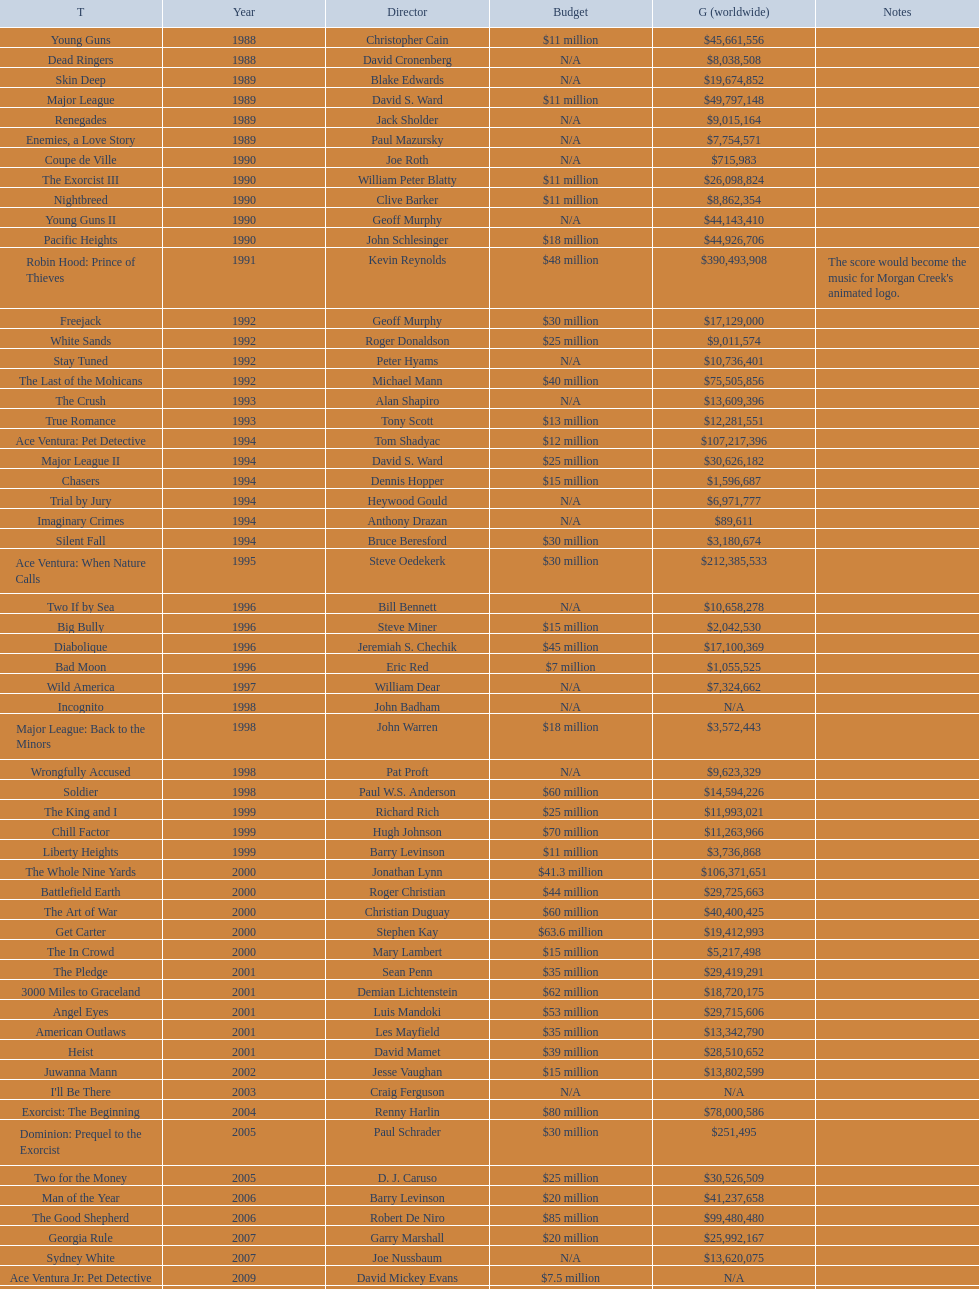Write the full table. {'header': ['T', 'Year', 'Director', 'Budget', 'G (worldwide)', 'Notes'], 'rows': [['Young Guns', '1988', 'Christopher Cain', '$11 million', '$45,661,556', ''], ['Dead Ringers', '1988', 'David Cronenberg', 'N/A', '$8,038,508', ''], ['Skin Deep', '1989', 'Blake Edwards', 'N/A', '$19,674,852', ''], ['Major League', '1989', 'David S. Ward', '$11 million', '$49,797,148', ''], ['Renegades', '1989', 'Jack Sholder', 'N/A', '$9,015,164', ''], ['Enemies, a Love Story', '1989', 'Paul Mazursky', 'N/A', '$7,754,571', ''], ['Coupe de Ville', '1990', 'Joe Roth', 'N/A', '$715,983', ''], ['The Exorcist III', '1990', 'William Peter Blatty', '$11 million', '$26,098,824', ''], ['Nightbreed', '1990', 'Clive Barker', '$11 million', '$8,862,354', ''], ['Young Guns II', '1990', 'Geoff Murphy', 'N/A', '$44,143,410', ''], ['Pacific Heights', '1990', 'John Schlesinger', '$18 million', '$44,926,706', ''], ['Robin Hood: Prince of Thieves', '1991', 'Kevin Reynolds', '$48 million', '$390,493,908', "The score would become the music for Morgan Creek's animated logo."], ['Freejack', '1992', 'Geoff Murphy', '$30 million', '$17,129,000', ''], ['White Sands', '1992', 'Roger Donaldson', '$25 million', '$9,011,574', ''], ['Stay Tuned', '1992', 'Peter Hyams', 'N/A', '$10,736,401', ''], ['The Last of the Mohicans', '1992', 'Michael Mann', '$40 million', '$75,505,856', ''], ['The Crush', '1993', 'Alan Shapiro', 'N/A', '$13,609,396', ''], ['True Romance', '1993', 'Tony Scott', '$13 million', '$12,281,551', ''], ['Ace Ventura: Pet Detective', '1994', 'Tom Shadyac', '$12 million', '$107,217,396', ''], ['Major League II', '1994', 'David S. Ward', '$25 million', '$30,626,182', ''], ['Chasers', '1994', 'Dennis Hopper', '$15 million', '$1,596,687', ''], ['Trial by Jury', '1994', 'Heywood Gould', 'N/A', '$6,971,777', ''], ['Imaginary Crimes', '1994', 'Anthony Drazan', 'N/A', '$89,611', ''], ['Silent Fall', '1994', 'Bruce Beresford', '$30 million', '$3,180,674', ''], ['Ace Ventura: When Nature Calls', '1995', 'Steve Oedekerk', '$30 million', '$212,385,533', ''], ['Two If by Sea', '1996', 'Bill Bennett', 'N/A', '$10,658,278', ''], ['Big Bully', '1996', 'Steve Miner', '$15 million', '$2,042,530', ''], ['Diabolique', '1996', 'Jeremiah S. Chechik', '$45 million', '$17,100,369', ''], ['Bad Moon', '1996', 'Eric Red', '$7 million', '$1,055,525', ''], ['Wild America', '1997', 'William Dear', 'N/A', '$7,324,662', ''], ['Incognito', '1998', 'John Badham', 'N/A', 'N/A', ''], ['Major League: Back to the Minors', '1998', 'John Warren', '$18 million', '$3,572,443', ''], ['Wrongfully Accused', '1998', 'Pat Proft', 'N/A', '$9,623,329', ''], ['Soldier', '1998', 'Paul W.S. Anderson', '$60 million', '$14,594,226', ''], ['The King and I', '1999', 'Richard Rich', '$25 million', '$11,993,021', ''], ['Chill Factor', '1999', 'Hugh Johnson', '$70 million', '$11,263,966', ''], ['Liberty Heights', '1999', 'Barry Levinson', '$11 million', '$3,736,868', ''], ['The Whole Nine Yards', '2000', 'Jonathan Lynn', '$41.3 million', '$106,371,651', ''], ['Battlefield Earth', '2000', 'Roger Christian', '$44 million', '$29,725,663', ''], ['The Art of War', '2000', 'Christian Duguay', '$60 million', '$40,400,425', ''], ['Get Carter', '2000', 'Stephen Kay', '$63.6 million', '$19,412,993', ''], ['The In Crowd', '2000', 'Mary Lambert', '$15 million', '$5,217,498', ''], ['The Pledge', '2001', 'Sean Penn', '$35 million', '$29,419,291', ''], ['3000 Miles to Graceland', '2001', 'Demian Lichtenstein', '$62 million', '$18,720,175', ''], ['Angel Eyes', '2001', 'Luis Mandoki', '$53 million', '$29,715,606', ''], ['American Outlaws', '2001', 'Les Mayfield', '$35 million', '$13,342,790', ''], ['Heist', '2001', 'David Mamet', '$39 million', '$28,510,652', ''], ['Juwanna Mann', '2002', 'Jesse Vaughan', '$15 million', '$13,802,599', ''], ["I'll Be There", '2003', 'Craig Ferguson', 'N/A', 'N/A', ''], ['Exorcist: The Beginning', '2004', 'Renny Harlin', '$80 million', '$78,000,586', ''], ['Dominion: Prequel to the Exorcist', '2005', 'Paul Schrader', '$30 million', '$251,495', ''], ['Two for the Money', '2005', 'D. J. Caruso', '$25 million', '$30,526,509', ''], ['Man of the Year', '2006', 'Barry Levinson', '$20 million', '$41,237,658', ''], ['The Good Shepherd', '2006', 'Robert De Niro', '$85 million', '$99,480,480', ''], ['Georgia Rule', '2007', 'Garry Marshall', '$20 million', '$25,992,167', ''], ['Sydney White', '2007', 'Joe Nussbaum', 'N/A', '$13,620,075', ''], ['Ace Ventura Jr: Pet Detective', '2009', 'David Mickey Evans', '$7.5 million', 'N/A', ''], ['Dream House', '2011', 'Jim Sheridan', '$50 million', '$38,502,340', ''], ['The Thing', '2011', 'Matthijs van Heijningen Jr.', '$38 million', '$27,428,670', ''], ['Tupac', '2014', 'Antoine Fuqua', '$45 million', '', '']]} Did the budget of young guns exceed or fall short of freejack's budget? Less. 